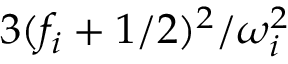<formula> <loc_0><loc_0><loc_500><loc_500>{ 3 ( f _ { i } + 1 / 2 ) ^ { 2 } } / { \omega _ { i } ^ { 2 } }</formula> 